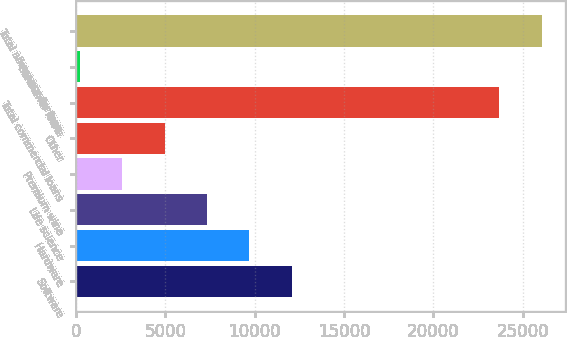Convert chart to OTSL. <chart><loc_0><loc_0><loc_500><loc_500><bar_chart><fcel>Software<fcel>Hardware<fcel>Life science<fcel>Premium wine<fcel>Other<fcel>Total commercial loans<fcel>Consumer loans<fcel>Total allowance for loan<nl><fcel>12062<fcel>9693.6<fcel>7325.2<fcel>2588.4<fcel>4956.8<fcel>23684<fcel>220<fcel>26052.4<nl></chart> 